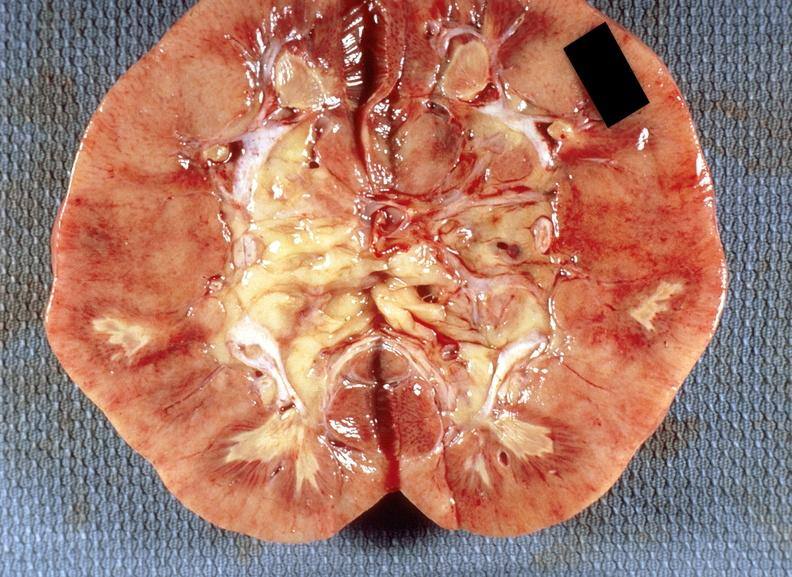does lung show kidney, renal papillary necrosis, acute?
Answer the question using a single word or phrase. No 